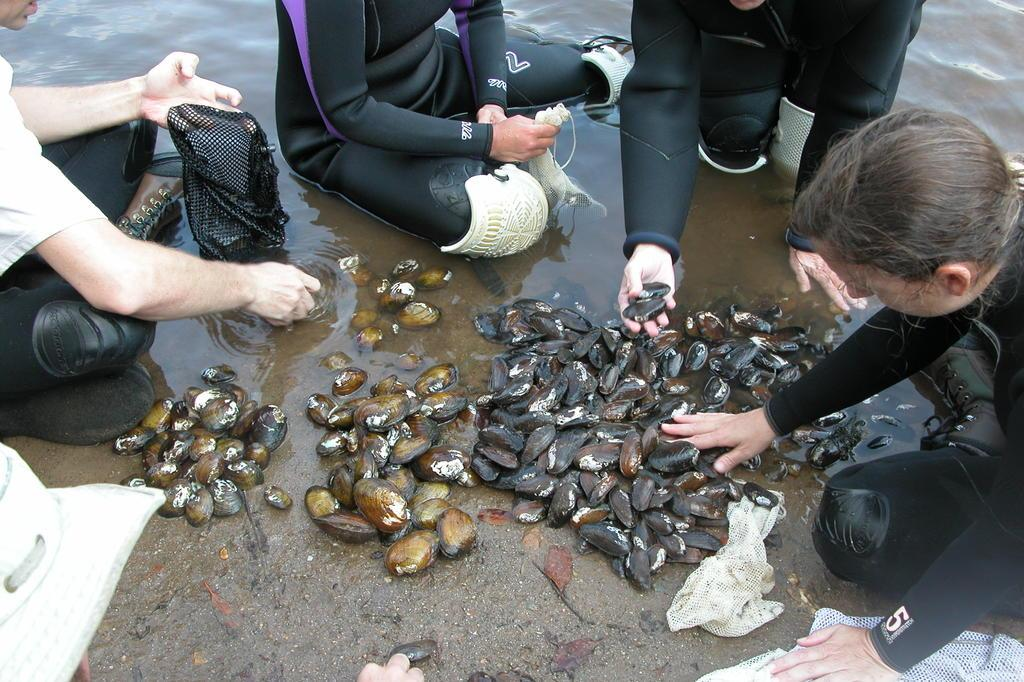Who are the subjects in the image? There are people in the image. What are the people doing in the image? The people are collecting shell fishes. Can you describe the environment where the people are collecting shell fishes? There are shell fishes on the ground, and there is a water body in the image. What type of rose can be seen growing near the water body in the image? There is no rose present in the image; it features people collecting shell fishes near a water body. 